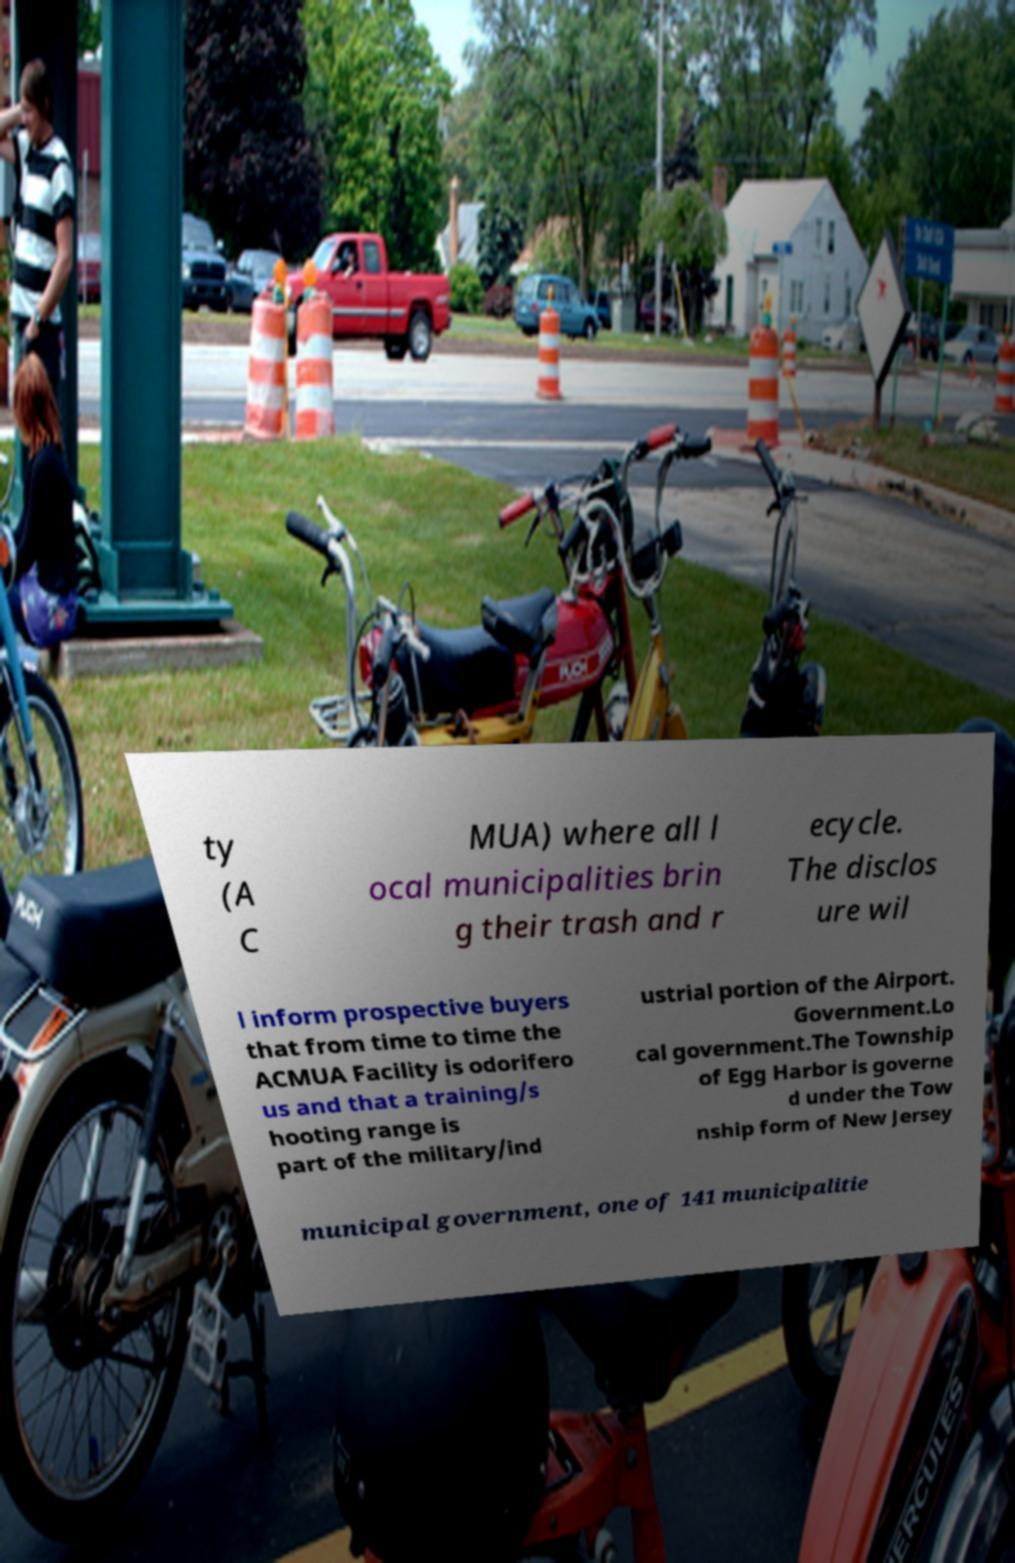For documentation purposes, I need the text within this image transcribed. Could you provide that? ty (A C MUA) where all l ocal municipalities brin g their trash and r ecycle. The disclos ure wil l inform prospective buyers that from time to time the ACMUA Facility is odorifero us and that a training/s hooting range is part of the military/ind ustrial portion of the Airport. Government.Lo cal government.The Township of Egg Harbor is governe d under the Tow nship form of New Jersey municipal government, one of 141 municipalitie 